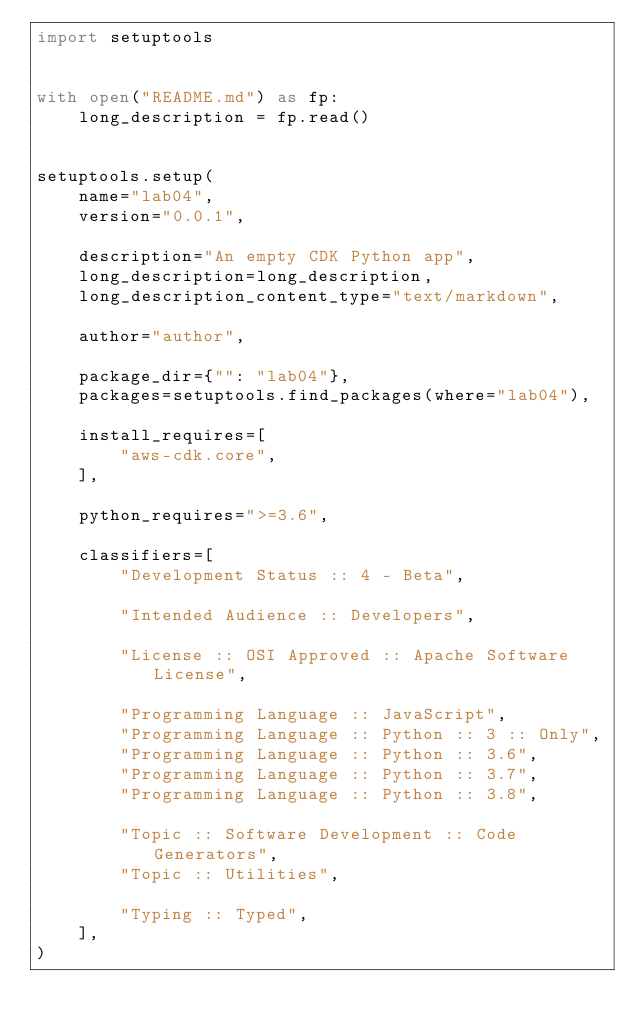<code> <loc_0><loc_0><loc_500><loc_500><_Python_>import setuptools


with open("README.md") as fp:
    long_description = fp.read()


setuptools.setup(
    name="lab04",
    version="0.0.1",

    description="An empty CDK Python app",
    long_description=long_description,
    long_description_content_type="text/markdown",

    author="author",

    package_dir={"": "lab04"},
    packages=setuptools.find_packages(where="lab04"),

    install_requires=[
        "aws-cdk.core",
    ],

    python_requires=">=3.6",

    classifiers=[
        "Development Status :: 4 - Beta",

        "Intended Audience :: Developers",

        "License :: OSI Approved :: Apache Software License",

        "Programming Language :: JavaScript",
        "Programming Language :: Python :: 3 :: Only",
        "Programming Language :: Python :: 3.6",
        "Programming Language :: Python :: 3.7",
        "Programming Language :: Python :: 3.8",

        "Topic :: Software Development :: Code Generators",
        "Topic :: Utilities",

        "Typing :: Typed",
    ],
)
</code> 